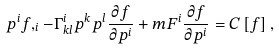<formula> <loc_0><loc_0><loc_500><loc_500>p ^ { i } f , _ { i } - \Gamma ^ { i } _ { k l } p ^ { k } p ^ { l } \frac { \partial f } { \partial p ^ { i } } + m F ^ { i } \frac { \partial { f } } { \partial { p ^ { i } } } = C \left [ f \right ] ,</formula> 